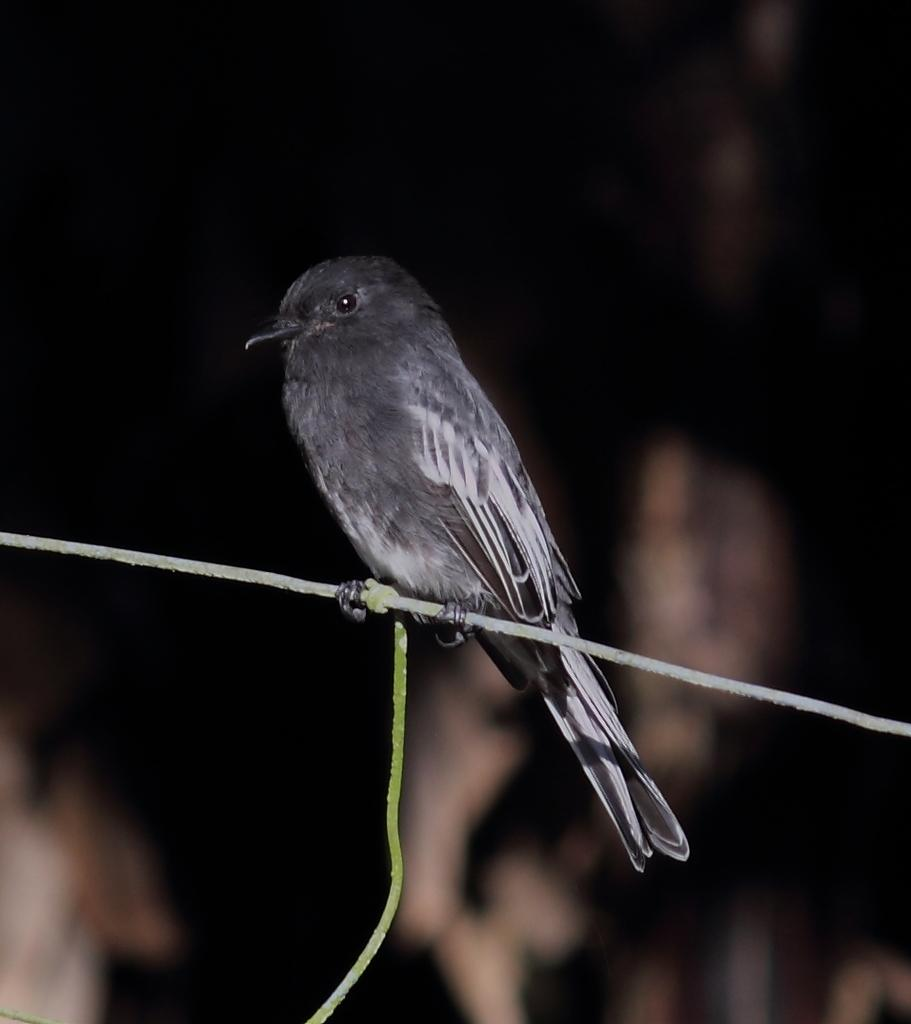What can be seen in the image that is made of wire? There is a wire in the image. What is sitting on the wire? A black and white colored bird is present on the wire. What is the color of the background in the image? The background of the image appears to be black in color. How many hours of sleep does the bird on the wire need? The image does not provide information about the bird's sleep habits, so we cannot determine how many hours of sleep it needs. 